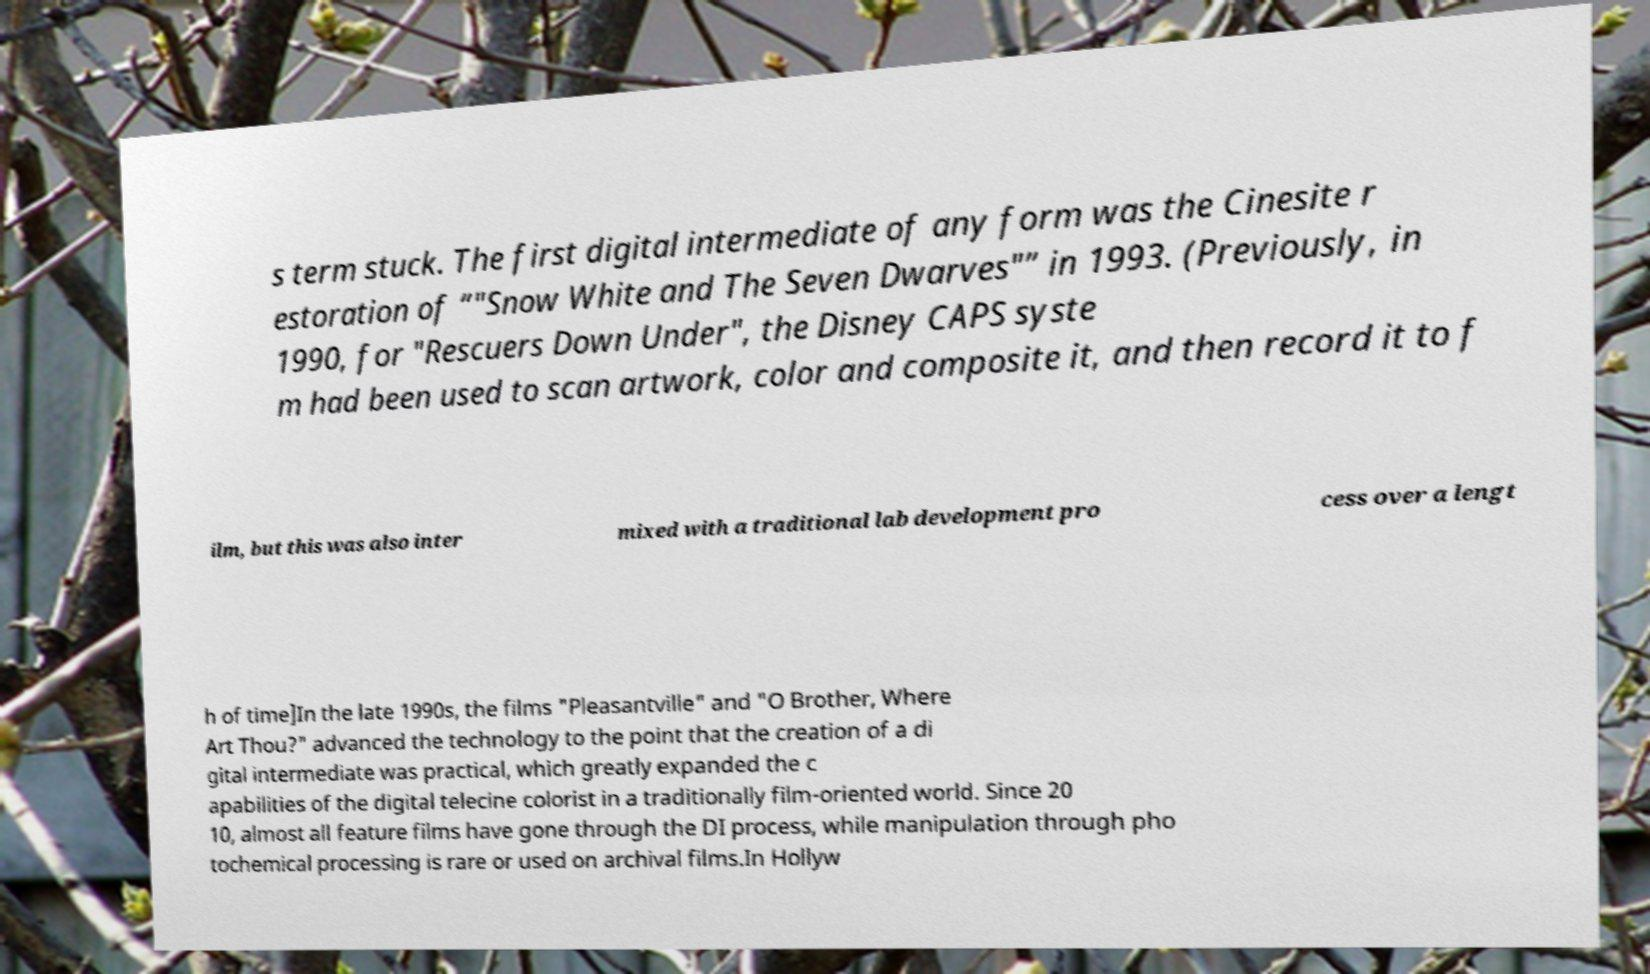Can you read and provide the text displayed in the image?This photo seems to have some interesting text. Can you extract and type it out for me? s term stuck. The first digital intermediate of any form was the Cinesite r estoration of “"Snow White and The Seven Dwarves"” in 1993. (Previously, in 1990, for "Rescuers Down Under", the Disney CAPS syste m had been used to scan artwork, color and composite it, and then record it to f ilm, but this was also inter mixed with a traditional lab development pro cess over a lengt h of time]In the late 1990s, the films "Pleasantville" and "O Brother, Where Art Thou?" advanced the technology to the point that the creation of a di gital intermediate was practical, which greatly expanded the c apabilities of the digital telecine colorist in a traditionally film-oriented world. Since 20 10, almost all feature films have gone through the DI process, while manipulation through pho tochemical processing is rare or used on archival films.In Hollyw 